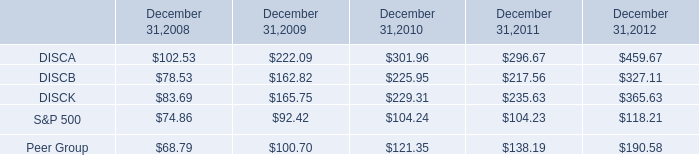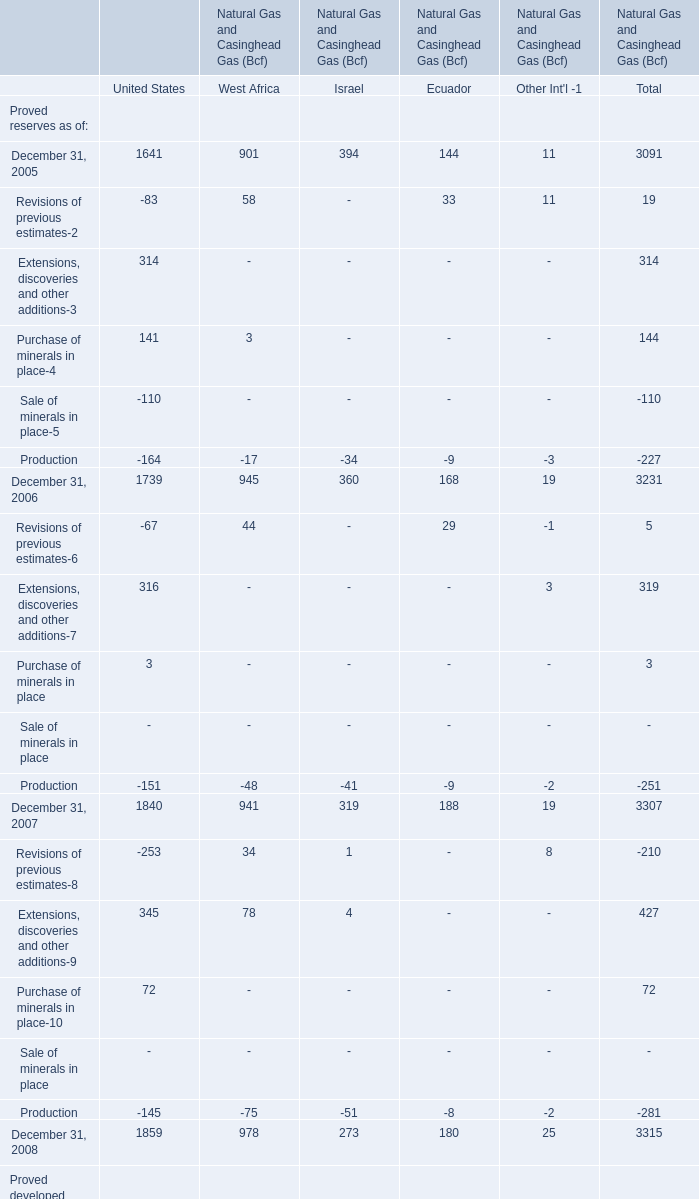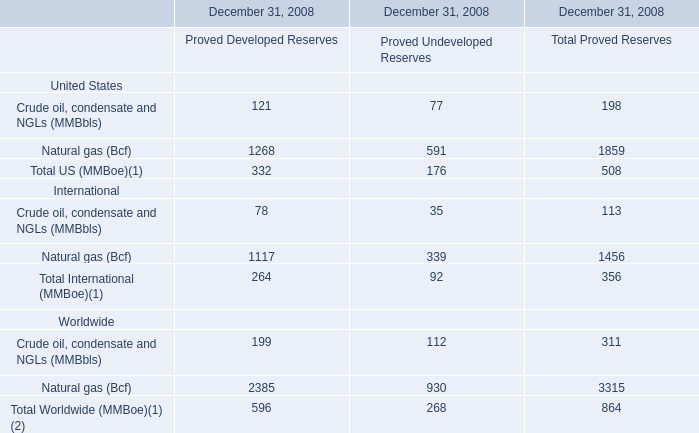what was the 5 year average total return for the a and c series of stock?\\n\\n\\n 
Computations: ((327.11 + 365.63) / 2)
Answer: 346.37. 